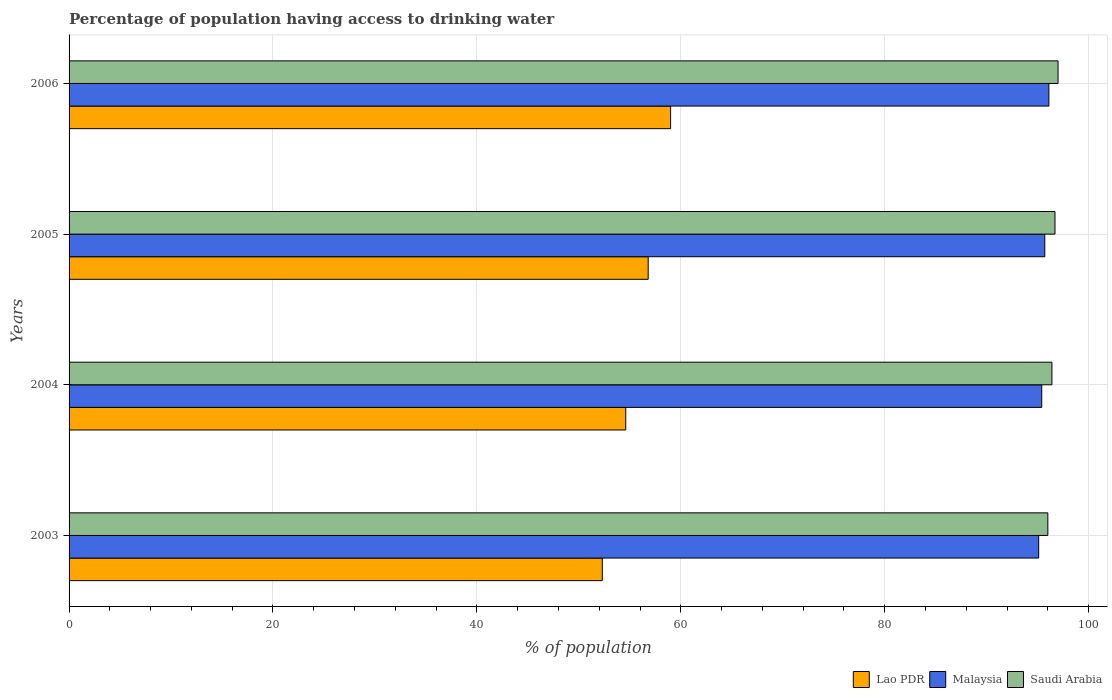How many different coloured bars are there?
Provide a succinct answer. 3. Are the number of bars per tick equal to the number of legend labels?
Provide a succinct answer. Yes. How many bars are there on the 1st tick from the bottom?
Provide a succinct answer. 3. In how many cases, is the number of bars for a given year not equal to the number of legend labels?
Keep it short and to the point. 0. Across all years, what is the minimum percentage of population having access to drinking water in Saudi Arabia?
Make the answer very short. 96. In which year was the percentage of population having access to drinking water in Saudi Arabia maximum?
Make the answer very short. 2006. What is the total percentage of population having access to drinking water in Lao PDR in the graph?
Ensure brevity in your answer.  222.7. What is the difference between the percentage of population having access to drinking water in Malaysia in 2003 and that in 2004?
Give a very brief answer. -0.3. What is the difference between the percentage of population having access to drinking water in Lao PDR in 2004 and the percentage of population having access to drinking water in Saudi Arabia in 2003?
Your response must be concise. -41.4. What is the average percentage of population having access to drinking water in Saudi Arabia per year?
Your response must be concise. 96.53. In the year 2004, what is the difference between the percentage of population having access to drinking water in Lao PDR and percentage of population having access to drinking water in Saudi Arabia?
Your response must be concise. -41.8. In how many years, is the percentage of population having access to drinking water in Malaysia greater than 8 %?
Provide a succinct answer. 4. What is the ratio of the percentage of population having access to drinking water in Malaysia in 2003 to that in 2004?
Your response must be concise. 1. Is the percentage of population having access to drinking water in Lao PDR in 2003 less than that in 2006?
Give a very brief answer. Yes. Is the difference between the percentage of population having access to drinking water in Lao PDR in 2004 and 2005 greater than the difference between the percentage of population having access to drinking water in Saudi Arabia in 2004 and 2005?
Your answer should be very brief. No. What is the difference between the highest and the second highest percentage of population having access to drinking water in Saudi Arabia?
Ensure brevity in your answer.  0.3. What is the difference between the highest and the lowest percentage of population having access to drinking water in Lao PDR?
Your answer should be compact. 6.7. In how many years, is the percentage of population having access to drinking water in Saudi Arabia greater than the average percentage of population having access to drinking water in Saudi Arabia taken over all years?
Make the answer very short. 2. What does the 1st bar from the top in 2005 represents?
Offer a very short reply. Saudi Arabia. What does the 2nd bar from the bottom in 2003 represents?
Give a very brief answer. Malaysia. Is it the case that in every year, the sum of the percentage of population having access to drinking water in Malaysia and percentage of population having access to drinking water in Lao PDR is greater than the percentage of population having access to drinking water in Saudi Arabia?
Provide a succinct answer. Yes. How many bars are there?
Provide a succinct answer. 12. Are all the bars in the graph horizontal?
Provide a succinct answer. Yes. What is the difference between two consecutive major ticks on the X-axis?
Your answer should be compact. 20. Are the values on the major ticks of X-axis written in scientific E-notation?
Your answer should be compact. No. Does the graph contain any zero values?
Give a very brief answer. No. Where does the legend appear in the graph?
Provide a succinct answer. Bottom right. How are the legend labels stacked?
Make the answer very short. Horizontal. What is the title of the graph?
Make the answer very short. Percentage of population having access to drinking water. Does "Sudan" appear as one of the legend labels in the graph?
Your response must be concise. No. What is the label or title of the X-axis?
Offer a terse response. % of population. What is the % of population of Lao PDR in 2003?
Your answer should be compact. 52.3. What is the % of population in Malaysia in 2003?
Keep it short and to the point. 95.1. What is the % of population in Saudi Arabia in 2003?
Give a very brief answer. 96. What is the % of population in Lao PDR in 2004?
Make the answer very short. 54.6. What is the % of population of Malaysia in 2004?
Offer a terse response. 95.4. What is the % of population of Saudi Arabia in 2004?
Offer a terse response. 96.4. What is the % of population in Lao PDR in 2005?
Your answer should be compact. 56.8. What is the % of population in Malaysia in 2005?
Keep it short and to the point. 95.7. What is the % of population of Saudi Arabia in 2005?
Ensure brevity in your answer.  96.7. What is the % of population in Malaysia in 2006?
Provide a succinct answer. 96.1. What is the % of population in Saudi Arabia in 2006?
Offer a terse response. 97. Across all years, what is the maximum % of population of Lao PDR?
Offer a very short reply. 59. Across all years, what is the maximum % of population of Malaysia?
Your answer should be very brief. 96.1. Across all years, what is the maximum % of population of Saudi Arabia?
Your answer should be compact. 97. Across all years, what is the minimum % of population of Lao PDR?
Give a very brief answer. 52.3. Across all years, what is the minimum % of population of Malaysia?
Ensure brevity in your answer.  95.1. Across all years, what is the minimum % of population in Saudi Arabia?
Your answer should be compact. 96. What is the total % of population in Lao PDR in the graph?
Your answer should be compact. 222.7. What is the total % of population of Malaysia in the graph?
Make the answer very short. 382.3. What is the total % of population of Saudi Arabia in the graph?
Ensure brevity in your answer.  386.1. What is the difference between the % of population in Lao PDR in 2003 and that in 2004?
Your answer should be very brief. -2.3. What is the difference between the % of population in Malaysia in 2003 and that in 2004?
Make the answer very short. -0.3. What is the difference between the % of population of Saudi Arabia in 2003 and that in 2004?
Provide a short and direct response. -0.4. What is the difference between the % of population of Malaysia in 2003 and that in 2005?
Your answer should be very brief. -0.6. What is the difference between the % of population in Lao PDR in 2003 and that in 2006?
Offer a terse response. -6.7. What is the difference between the % of population of Lao PDR in 2004 and that in 2005?
Make the answer very short. -2.2. What is the difference between the % of population in Saudi Arabia in 2004 and that in 2005?
Provide a short and direct response. -0.3. What is the difference between the % of population of Lao PDR in 2004 and that in 2006?
Provide a succinct answer. -4.4. What is the difference between the % of population in Malaysia in 2004 and that in 2006?
Provide a succinct answer. -0.7. What is the difference between the % of population of Malaysia in 2005 and that in 2006?
Provide a succinct answer. -0.4. What is the difference between the % of population of Lao PDR in 2003 and the % of population of Malaysia in 2004?
Your answer should be compact. -43.1. What is the difference between the % of population in Lao PDR in 2003 and the % of population in Saudi Arabia in 2004?
Your answer should be very brief. -44.1. What is the difference between the % of population of Lao PDR in 2003 and the % of population of Malaysia in 2005?
Give a very brief answer. -43.4. What is the difference between the % of population in Lao PDR in 2003 and the % of population in Saudi Arabia in 2005?
Offer a terse response. -44.4. What is the difference between the % of population in Malaysia in 2003 and the % of population in Saudi Arabia in 2005?
Give a very brief answer. -1.6. What is the difference between the % of population in Lao PDR in 2003 and the % of population in Malaysia in 2006?
Provide a short and direct response. -43.8. What is the difference between the % of population in Lao PDR in 2003 and the % of population in Saudi Arabia in 2006?
Your answer should be very brief. -44.7. What is the difference between the % of population in Malaysia in 2003 and the % of population in Saudi Arabia in 2006?
Give a very brief answer. -1.9. What is the difference between the % of population of Lao PDR in 2004 and the % of population of Malaysia in 2005?
Ensure brevity in your answer.  -41.1. What is the difference between the % of population of Lao PDR in 2004 and the % of population of Saudi Arabia in 2005?
Your response must be concise. -42.1. What is the difference between the % of population in Malaysia in 2004 and the % of population in Saudi Arabia in 2005?
Provide a short and direct response. -1.3. What is the difference between the % of population in Lao PDR in 2004 and the % of population in Malaysia in 2006?
Provide a succinct answer. -41.5. What is the difference between the % of population of Lao PDR in 2004 and the % of population of Saudi Arabia in 2006?
Offer a terse response. -42.4. What is the difference between the % of population in Malaysia in 2004 and the % of population in Saudi Arabia in 2006?
Give a very brief answer. -1.6. What is the difference between the % of population of Lao PDR in 2005 and the % of population of Malaysia in 2006?
Make the answer very short. -39.3. What is the difference between the % of population in Lao PDR in 2005 and the % of population in Saudi Arabia in 2006?
Your answer should be very brief. -40.2. What is the difference between the % of population of Malaysia in 2005 and the % of population of Saudi Arabia in 2006?
Keep it short and to the point. -1.3. What is the average % of population of Lao PDR per year?
Provide a succinct answer. 55.67. What is the average % of population of Malaysia per year?
Your response must be concise. 95.58. What is the average % of population in Saudi Arabia per year?
Your answer should be very brief. 96.53. In the year 2003, what is the difference between the % of population of Lao PDR and % of population of Malaysia?
Ensure brevity in your answer.  -42.8. In the year 2003, what is the difference between the % of population in Lao PDR and % of population in Saudi Arabia?
Ensure brevity in your answer.  -43.7. In the year 2003, what is the difference between the % of population in Malaysia and % of population in Saudi Arabia?
Ensure brevity in your answer.  -0.9. In the year 2004, what is the difference between the % of population of Lao PDR and % of population of Malaysia?
Offer a terse response. -40.8. In the year 2004, what is the difference between the % of population in Lao PDR and % of population in Saudi Arabia?
Give a very brief answer. -41.8. In the year 2005, what is the difference between the % of population of Lao PDR and % of population of Malaysia?
Provide a short and direct response. -38.9. In the year 2005, what is the difference between the % of population in Lao PDR and % of population in Saudi Arabia?
Ensure brevity in your answer.  -39.9. In the year 2006, what is the difference between the % of population in Lao PDR and % of population in Malaysia?
Provide a succinct answer. -37.1. In the year 2006, what is the difference between the % of population in Lao PDR and % of population in Saudi Arabia?
Make the answer very short. -38. What is the ratio of the % of population in Lao PDR in 2003 to that in 2004?
Give a very brief answer. 0.96. What is the ratio of the % of population of Saudi Arabia in 2003 to that in 2004?
Make the answer very short. 1. What is the ratio of the % of population of Lao PDR in 2003 to that in 2005?
Make the answer very short. 0.92. What is the ratio of the % of population in Lao PDR in 2003 to that in 2006?
Give a very brief answer. 0.89. What is the ratio of the % of population in Lao PDR in 2004 to that in 2005?
Your response must be concise. 0.96. What is the ratio of the % of population of Saudi Arabia in 2004 to that in 2005?
Make the answer very short. 1. What is the ratio of the % of population of Lao PDR in 2004 to that in 2006?
Provide a succinct answer. 0.93. What is the ratio of the % of population in Saudi Arabia in 2004 to that in 2006?
Your answer should be compact. 0.99. What is the ratio of the % of population in Lao PDR in 2005 to that in 2006?
Keep it short and to the point. 0.96. What is the ratio of the % of population in Malaysia in 2005 to that in 2006?
Offer a terse response. 1. What is the difference between the highest and the second highest % of population of Malaysia?
Offer a terse response. 0.4. What is the difference between the highest and the lowest % of population of Lao PDR?
Make the answer very short. 6.7. What is the difference between the highest and the lowest % of population in Saudi Arabia?
Your response must be concise. 1. 